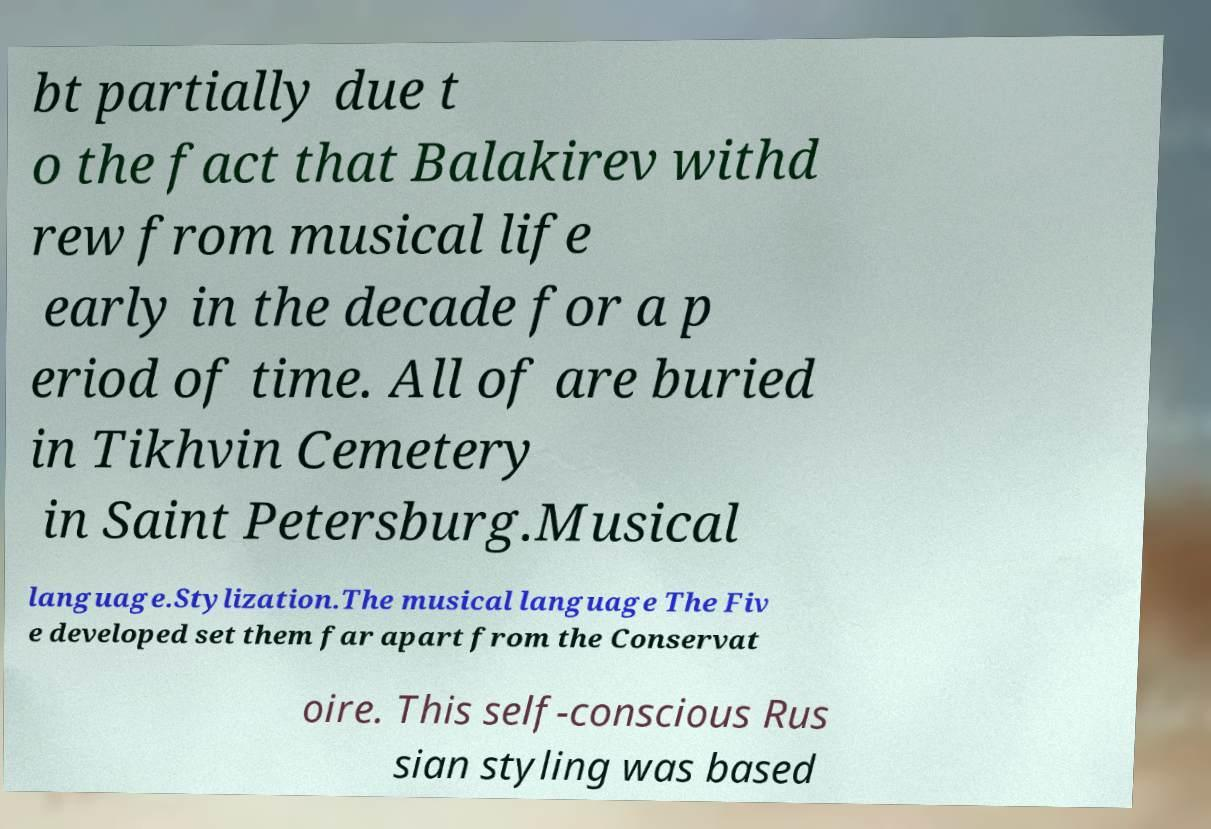Could you assist in decoding the text presented in this image and type it out clearly? bt partially due t o the fact that Balakirev withd rew from musical life early in the decade for a p eriod of time. All of are buried in Tikhvin Cemetery in Saint Petersburg.Musical language.Stylization.The musical language The Fiv e developed set them far apart from the Conservat oire. This self-conscious Rus sian styling was based 